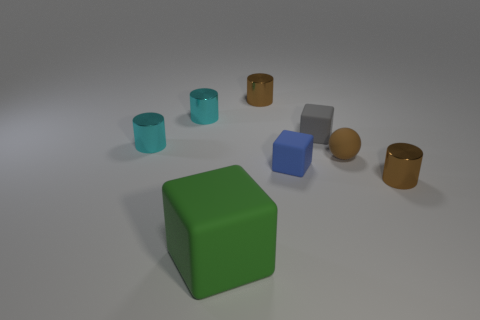How is the lighting set up in this scene? The lighting in this scene appears to be diffuse overhead lighting, as indicated by the soft shadows under the objects. There's no harsh or direct light source visible, suggesting an ambient lighting setup that evenly illuminates the entire scene without creating sharp highlights. 